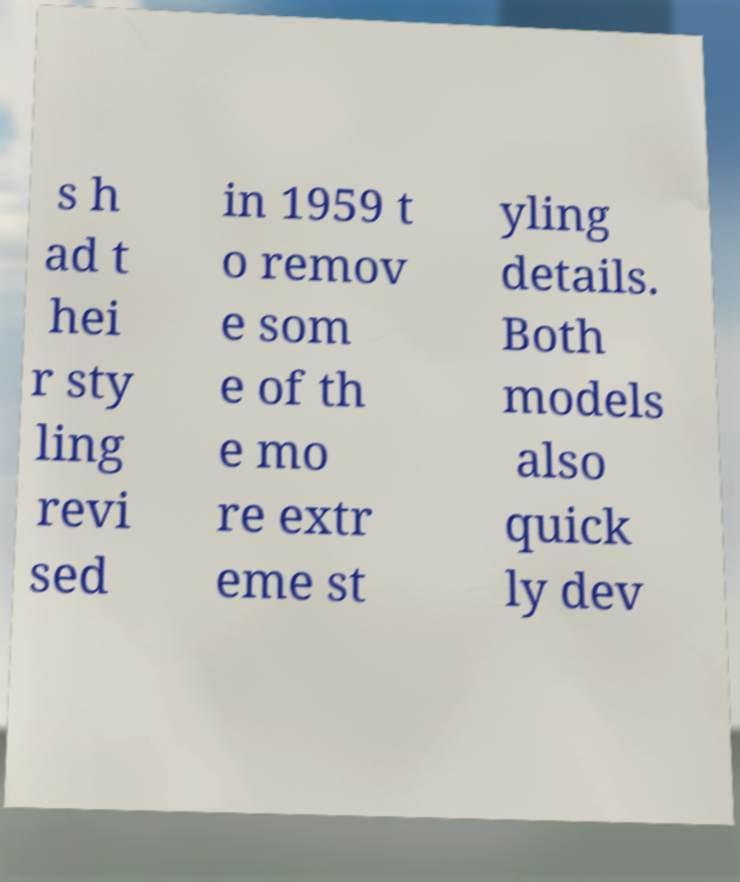Can you read and provide the text displayed in the image?This photo seems to have some interesting text. Can you extract and type it out for me? s h ad t hei r sty ling revi sed in 1959 t o remov e som e of th e mo re extr eme st yling details. Both models also quick ly dev 